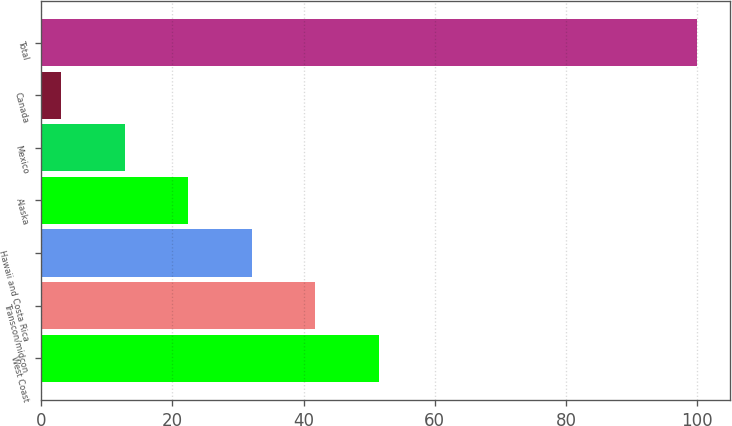Convert chart. <chart><loc_0><loc_0><loc_500><loc_500><bar_chart><fcel>West Coast<fcel>Transcon/midcon<fcel>Hawaii and Costa Rica<fcel>Alaska<fcel>Mexico<fcel>Canada<fcel>Total<nl><fcel>51.5<fcel>41.8<fcel>32.1<fcel>22.4<fcel>12.7<fcel>3<fcel>100<nl></chart> 